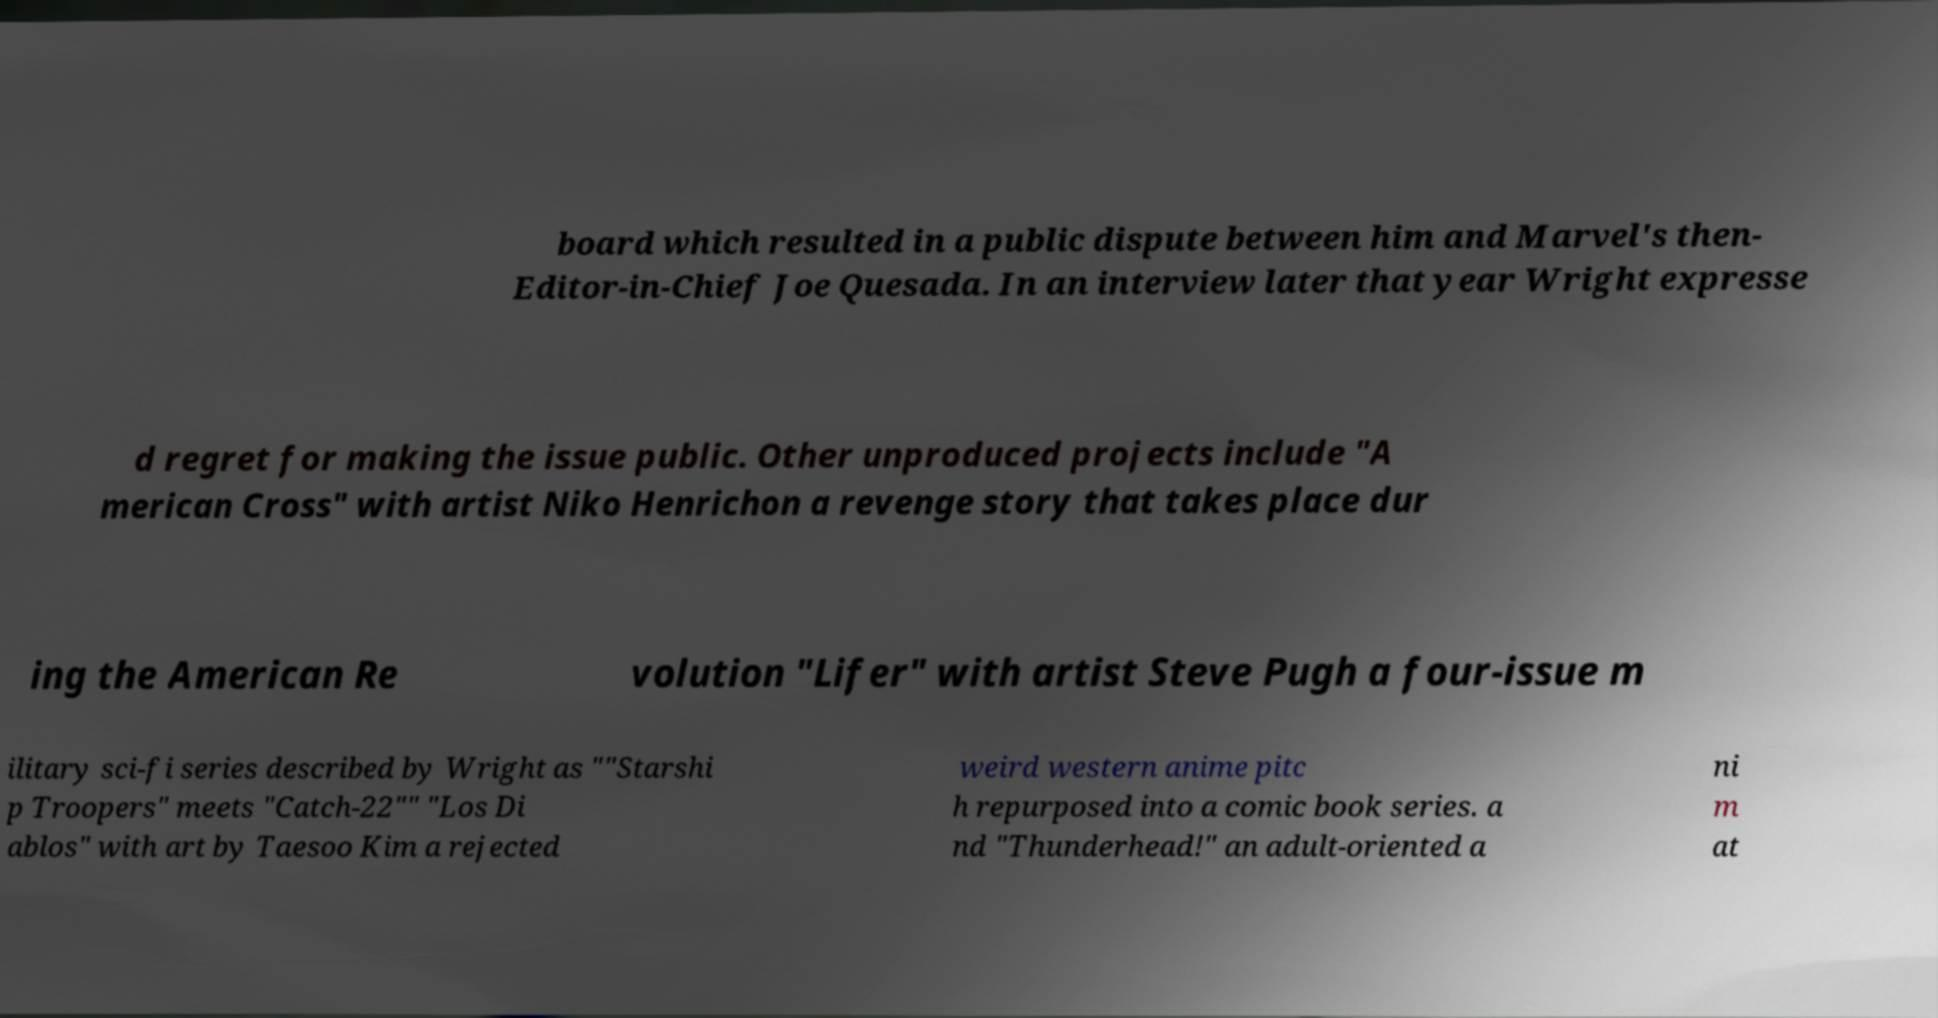What messages or text are displayed in this image? I need them in a readable, typed format. board which resulted in a public dispute between him and Marvel's then- Editor-in-Chief Joe Quesada. In an interview later that year Wright expresse d regret for making the issue public. Other unproduced projects include "A merican Cross" with artist Niko Henrichon a revenge story that takes place dur ing the American Re volution "Lifer" with artist Steve Pugh a four-issue m ilitary sci-fi series described by Wright as ""Starshi p Troopers" meets "Catch-22"" "Los Di ablos" with art by Taesoo Kim a rejected weird western anime pitc h repurposed into a comic book series. a nd "Thunderhead!" an adult-oriented a ni m at 